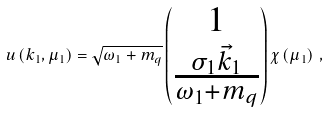<formula> <loc_0><loc_0><loc_500><loc_500>u \left ( { k _ { 1 } } , \mu _ { 1 } \right ) = \sqrt { \omega _ { 1 } + m _ { q } } \begin{pmatrix} 1 \\ \frac { \sigma _ { 1 } { \vec { k } _ { 1 } } } { \omega _ { 1 } + m _ { q } } \\ \end{pmatrix} \chi \left ( \mu _ { 1 } \right ) \, ,</formula> 